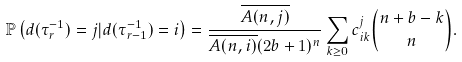Convert formula to latex. <formula><loc_0><loc_0><loc_500><loc_500>\mathbb { P } \left ( d ( \tau _ { r } ^ { - 1 } ) = j | d ( \tau _ { r - 1 } ^ { - 1 } ) = i \right ) = \frac { \overline { A ( n , j ) } } { \overline { A ( n , i ) } ( 2 b + 1 ) ^ { n } } \sum _ { k \geq 0 } c _ { i k } ^ { j } { n + b - k \choose n } .</formula> 